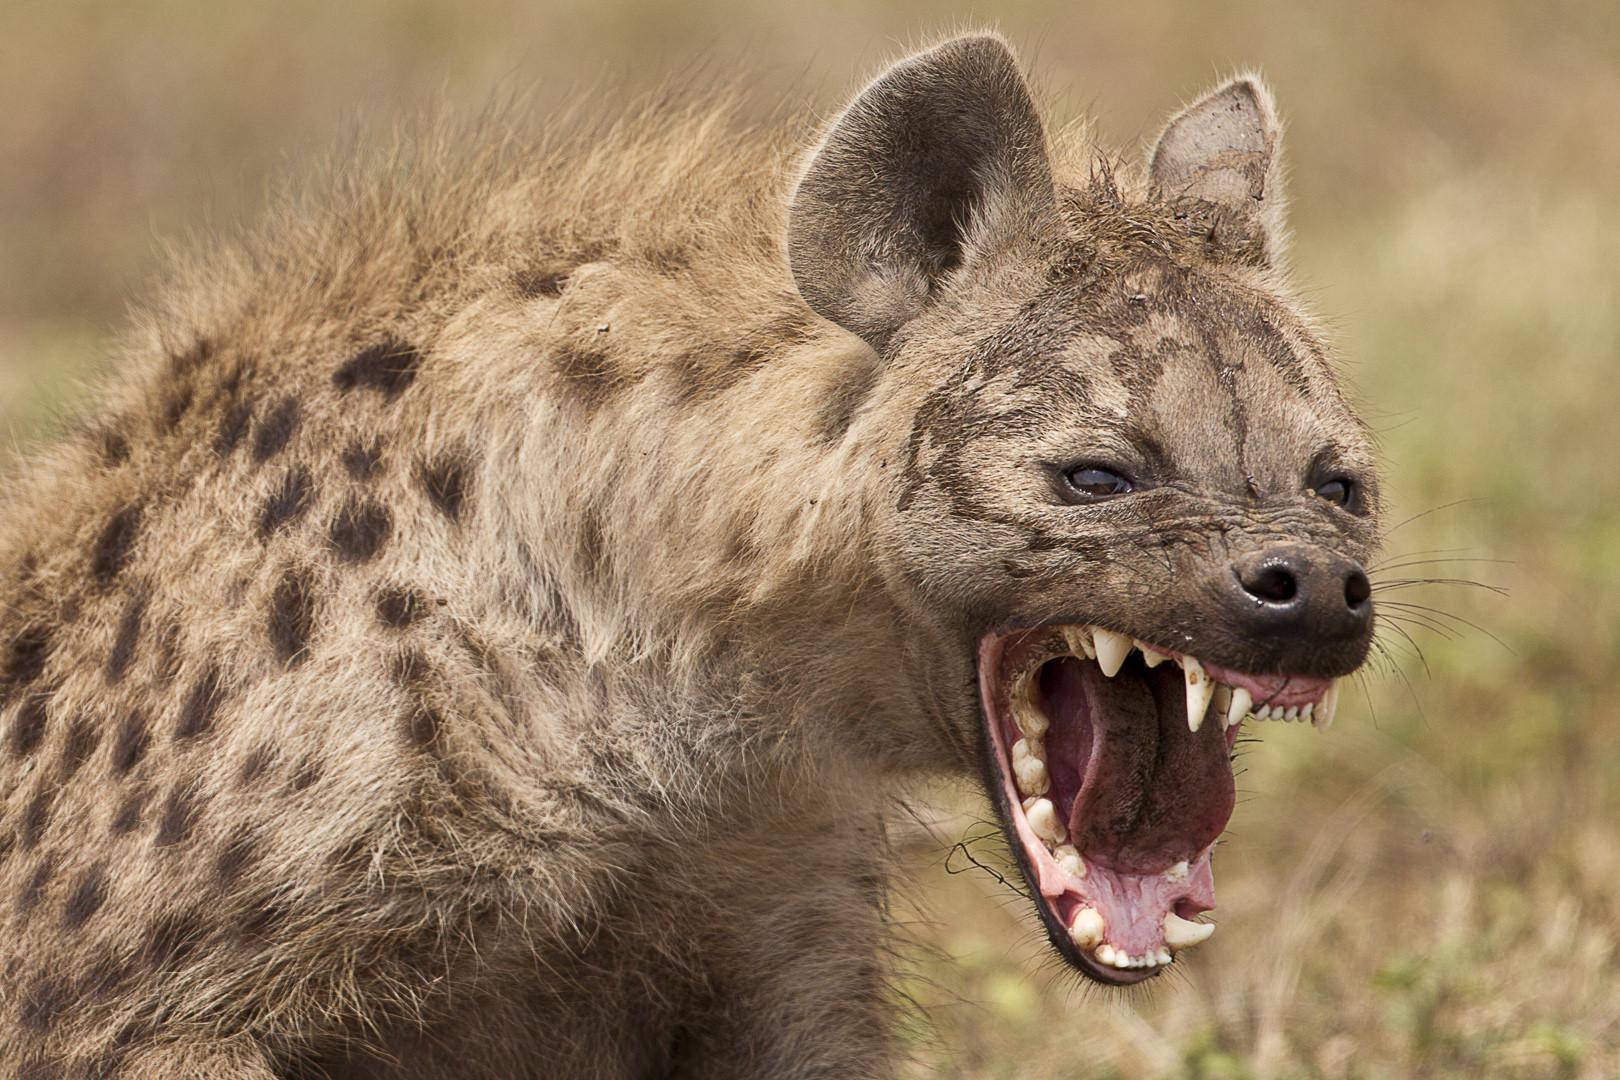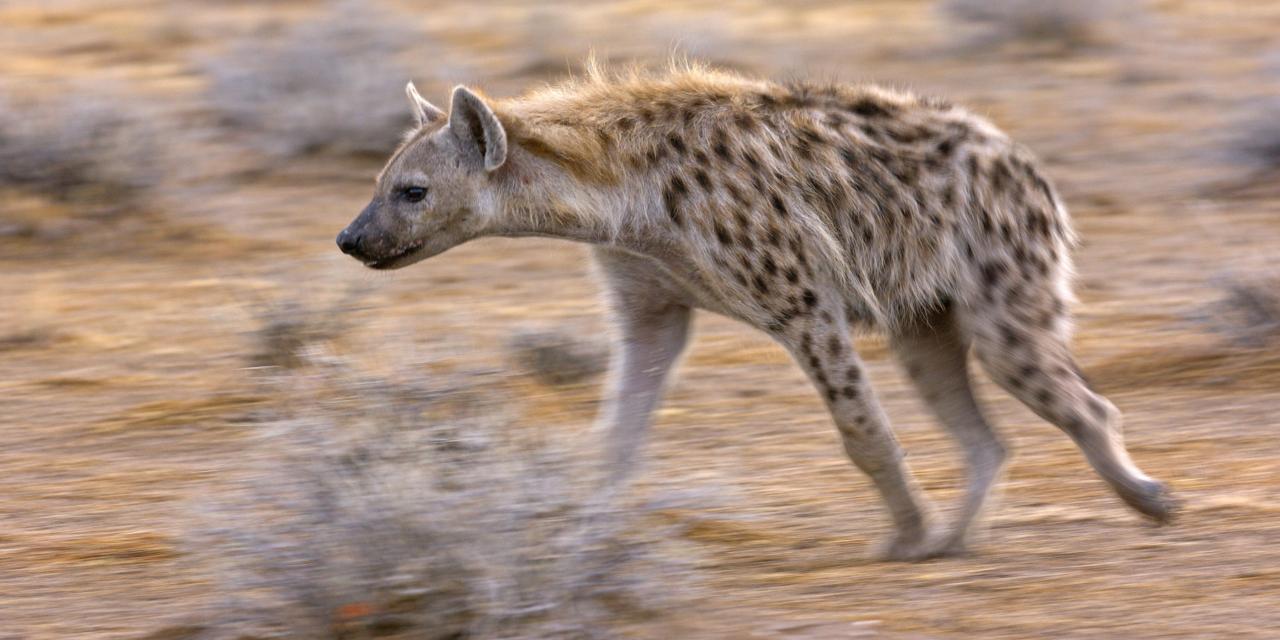The first image is the image on the left, the second image is the image on the right. Analyze the images presented: Is the assertion "A hyena has its mouth wide open" valid? Answer yes or no. Yes. 